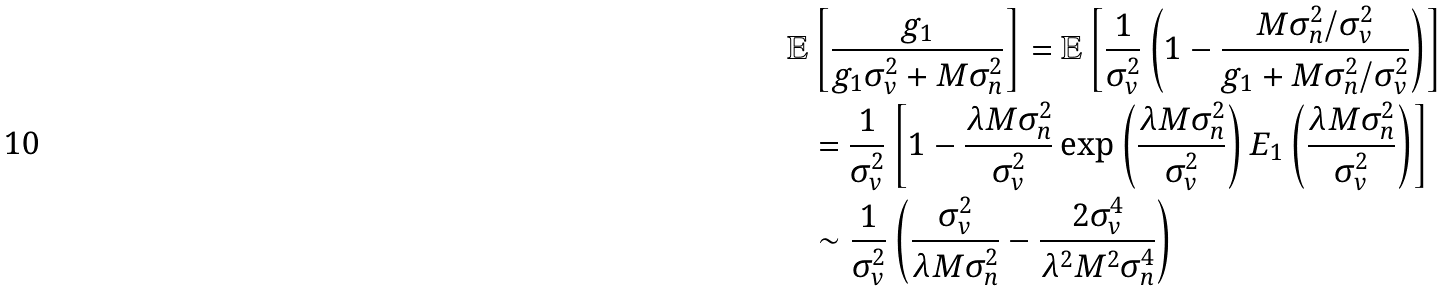Convert formula to latex. <formula><loc_0><loc_0><loc_500><loc_500>\mathbb { E } & \left [ \frac { g _ { 1 } } { g _ { 1 } \sigma _ { v } ^ { 2 } + M \sigma _ { n } ^ { 2 } } \right ] = \mathbb { E } \left [ \frac { 1 } { \sigma _ { v } ^ { 2 } } \left ( 1 - \frac { M \sigma _ { n } ^ { 2 } / \sigma _ { v } ^ { 2 } } { g _ { 1 } + M \sigma _ { n } ^ { 2 } / \sigma _ { v } ^ { 2 } } \right ) \right ] \\ & = \frac { 1 } { \sigma _ { v } ^ { 2 } } \left [ 1 - \frac { \lambda M \sigma _ { n } ^ { 2 } } { \sigma _ { v } ^ { 2 } } \exp \left ( \frac { \lambda M \sigma _ { n } ^ { 2 } } { \sigma _ { v } ^ { 2 } } \right ) E _ { 1 } \left ( \frac { \lambda M \sigma _ { n } ^ { 2 } } { \sigma _ { v } ^ { 2 } } \right ) \right ] \\ & \sim \frac { 1 } { \sigma _ { v } ^ { 2 } } \left ( \frac { \sigma _ { v } ^ { 2 } } { \lambda M \sigma _ { n } ^ { 2 } } - \frac { 2 \sigma _ { v } ^ { 4 } } { \lambda ^ { 2 } M ^ { 2 } \sigma _ { n } ^ { 4 } } \right )</formula> 